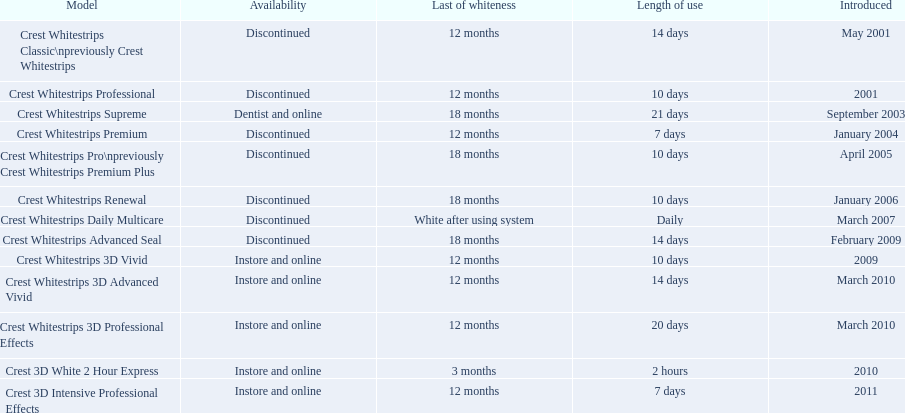What products are listed? Crest Whitestrips Classic\npreviously Crest Whitestrips, Crest Whitestrips Professional, Crest Whitestrips Supreme, Crest Whitestrips Premium, Crest Whitestrips Pro\npreviously Crest Whitestrips Premium Plus, Crest Whitestrips Renewal, Crest Whitestrips Daily Multicare, Crest Whitestrips Advanced Seal, Crest Whitestrips 3D Vivid, Crest Whitestrips 3D Advanced Vivid, Crest Whitestrips 3D Professional Effects, Crest 3D White 2 Hour Express, Crest 3D Intensive Professional Effects. Of these, which was were introduced in march, 2010? Crest Whitestrips 3D Advanced Vivid, Crest Whitestrips 3D Professional Effects. Of these, which were not 3d advanced vivid? Crest Whitestrips 3D Professional Effects. 